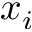Convert formula to latex. <formula><loc_0><loc_0><loc_500><loc_500>x _ { i }</formula> 